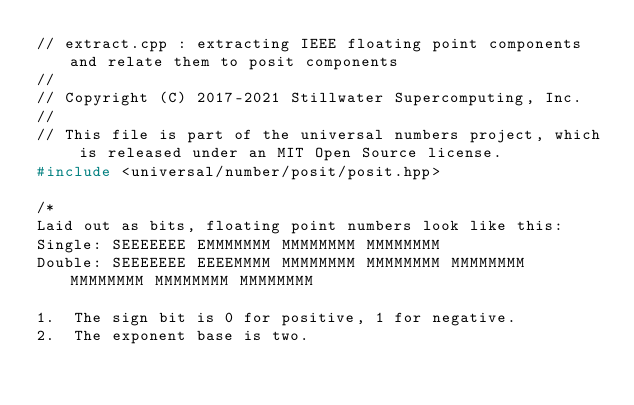Convert code to text. <code><loc_0><loc_0><loc_500><loc_500><_C++_>// extract.cpp : extracting IEEE floating point components and relate them to posit components
//
// Copyright (C) 2017-2021 Stillwater Supercomputing, Inc.
//
// This file is part of the universal numbers project, which is released under an MIT Open Source license.
#include <universal/number/posit/posit.hpp>

/*
Laid out as bits, floating point numbers look like this:
Single: SEEEEEEE EMMMMMMM MMMMMMMM MMMMMMMM
Double: SEEEEEEE EEEEMMMM MMMMMMMM MMMMMMMM MMMMMMMM MMMMMMMM MMMMMMMM MMMMMMMM

1.	The sign bit is 0 for positive, 1 for negative.
2.	The exponent base is two.</code> 